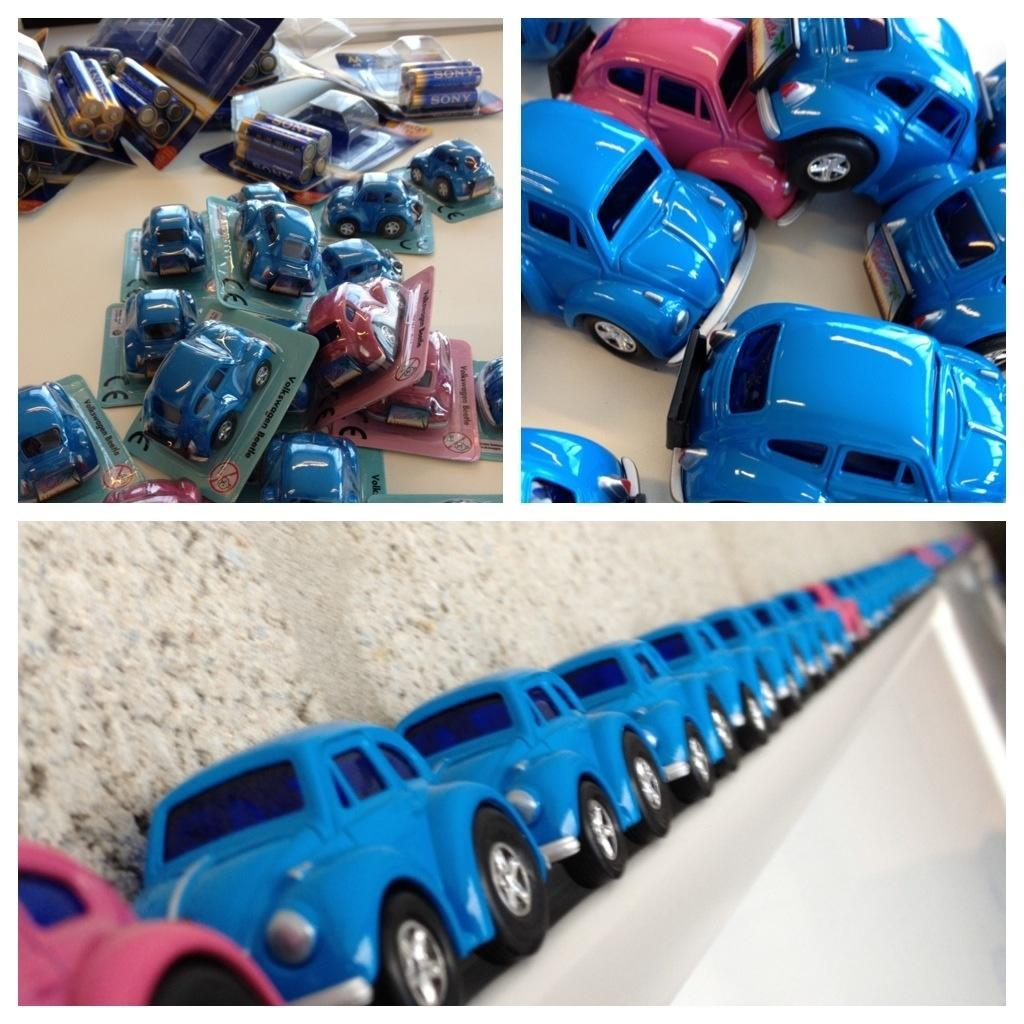How many images are included in the collage? The collage contains three images. What type of toys can be seen in the collage? There are toys of cars in the collage. What type of bottle is featured in the collage? There is no bottle present in the collage; it only contains images of car toys. 